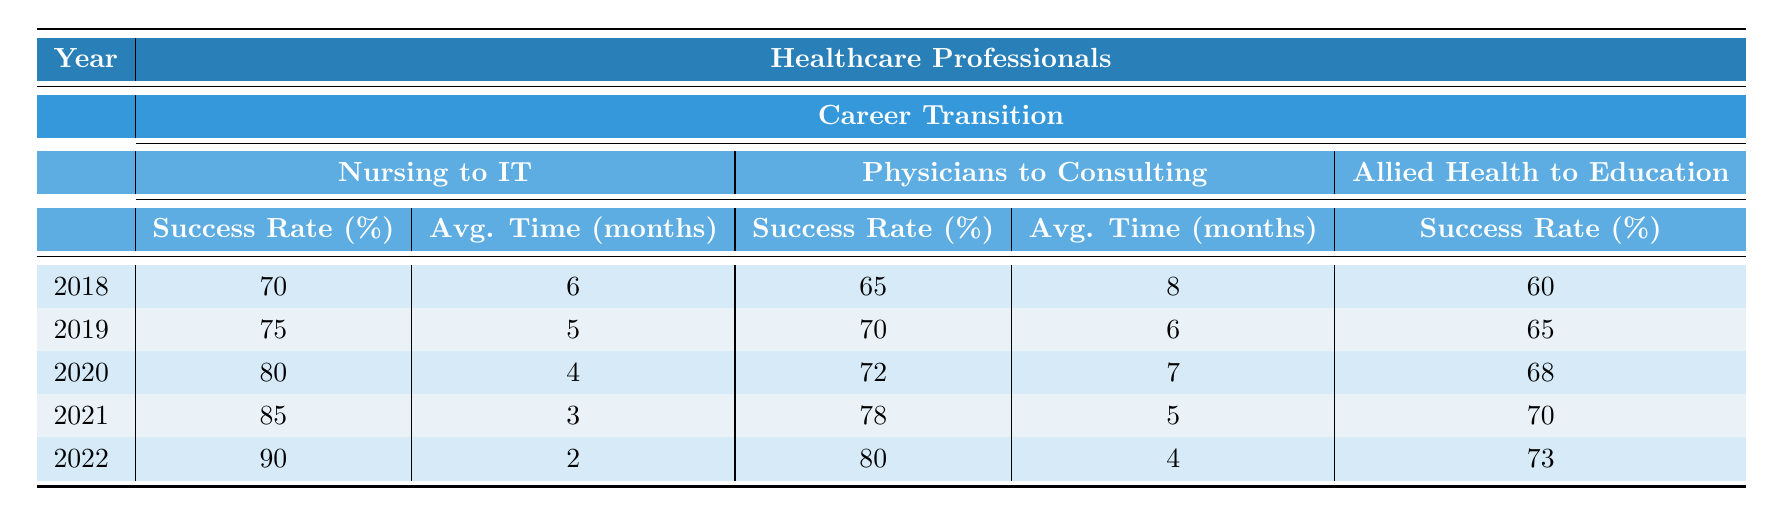What was the success rate for nursing to IT transitions in 2021? In the table, under the year 2021 and the nursing to IT transition category, the success rate listed is 85%.
Answer: 85% What is the average transition time for physicians to consulting roles in 2019? For the year 2019, the average transition time for physicians to consulting, as per the table, is 6 months.
Answer: 6 months Which career transition had the highest success rate in 2022? Looking at the year 2022: Nursing to IT had a success rate of 90%, which is the highest among the transitions in that year.
Answer: Nursing to IT What was the percentage increase in success rate for nursing to IT from 2018 to 2022? The success rate for nursing to IT in 2018 was 70% and in 2022 it was 90%. The increase is calculated as (90 - 70) = 20%.
Answer: 20% In which year did allied health to education have the highest success rate? By examining the table, the highest success rate for allied health to education was in 2022, at 73%.
Answer: 2022 What is the trend for the average transition time in nursing to IT from 2018 to 2022? The average transition time for nursing to IT decreased from 6 months in 2018 to 2 months in 2022, indicating a trend of decreasing transition time.
Answer: Decreasing For which year was the success rate for physicians to consulting the lowest? The table shows that the success rate for physicians to consulting was 65% in 2018, which is the lowest compared to other years.
Answer: 2018 What is the average success rate for allied health to education across all years provided? The success rates are: 60% (2018), 65% (2019), 68% (2020), 70% (2021), and 73% (2022). 
The total sum is 60 + 65 + 68 + 70 + 73 = 336, and there are 5 years. The average is 336/5 = 67.2%.
Answer: 67.2% Which transition consistently improved in success rate each year? Observing the table, the nursing to IT transition had success rates of 70%, 75%, 80%, 85%, and 90% from 2018 to 2022, showing a consistent improvement.
Answer: Nursing to IT How much did the success rate of physicians to consulting change from 2020 to 2021? The success rate for physicians to consulting in 2020 was 72%, and in 2021 it was 78%. The change is calculated as (78 - 72) = 6%.
Answer: 6% 